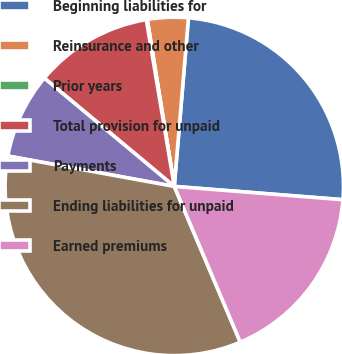Convert chart. <chart><loc_0><loc_0><loc_500><loc_500><pie_chart><fcel>Beginning liabilities for<fcel>Reinsurance and other<fcel>Prior years<fcel>Total provision for unpaid<fcel>Payments<fcel>Ending liabilities for unpaid<fcel>Earned premiums<nl><fcel>24.92%<fcel>3.89%<fcel>0.09%<fcel>11.3%<fcel>8.18%<fcel>34.26%<fcel>17.37%<nl></chart> 